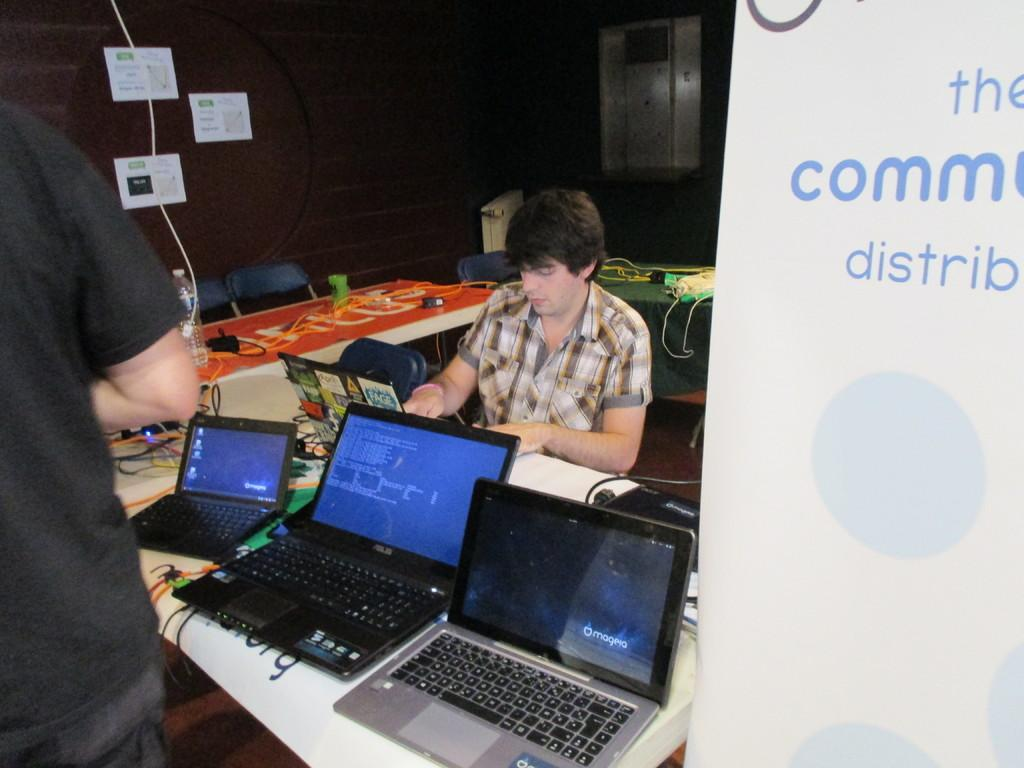<image>
Give a short and clear explanation of the subsequent image. a person in front of computers and sign reading The Comm Distrib 